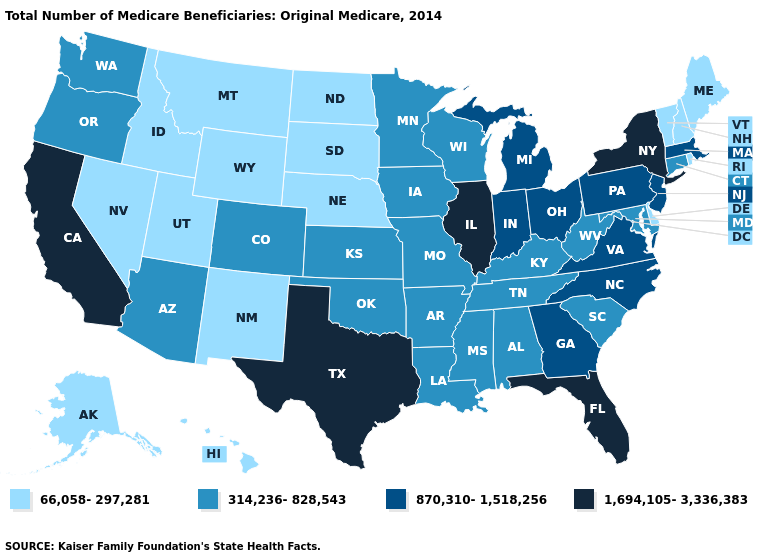What is the highest value in the West ?
Answer briefly. 1,694,105-3,336,383. What is the value of Iowa?
Short answer required. 314,236-828,543. Name the states that have a value in the range 1,694,105-3,336,383?
Short answer required. California, Florida, Illinois, New York, Texas. Name the states that have a value in the range 66,058-297,281?
Keep it brief. Alaska, Delaware, Hawaii, Idaho, Maine, Montana, Nebraska, Nevada, New Hampshire, New Mexico, North Dakota, Rhode Island, South Dakota, Utah, Vermont, Wyoming. Which states hav the highest value in the South?
Concise answer only. Florida, Texas. What is the lowest value in states that border New Hampshire?
Be succinct. 66,058-297,281. What is the value of Tennessee?
Write a very short answer. 314,236-828,543. Name the states that have a value in the range 66,058-297,281?
Keep it brief. Alaska, Delaware, Hawaii, Idaho, Maine, Montana, Nebraska, Nevada, New Hampshire, New Mexico, North Dakota, Rhode Island, South Dakota, Utah, Vermont, Wyoming. Name the states that have a value in the range 66,058-297,281?
Write a very short answer. Alaska, Delaware, Hawaii, Idaho, Maine, Montana, Nebraska, Nevada, New Hampshire, New Mexico, North Dakota, Rhode Island, South Dakota, Utah, Vermont, Wyoming. Does Idaho have the lowest value in the West?
Answer briefly. Yes. Name the states that have a value in the range 1,694,105-3,336,383?
Short answer required. California, Florida, Illinois, New York, Texas. Does California have the lowest value in the West?
Short answer required. No. What is the value of Arizona?
Be succinct. 314,236-828,543. Which states have the lowest value in the West?
Be succinct. Alaska, Hawaii, Idaho, Montana, Nevada, New Mexico, Utah, Wyoming. Name the states that have a value in the range 314,236-828,543?
Write a very short answer. Alabama, Arizona, Arkansas, Colorado, Connecticut, Iowa, Kansas, Kentucky, Louisiana, Maryland, Minnesota, Mississippi, Missouri, Oklahoma, Oregon, South Carolina, Tennessee, Washington, West Virginia, Wisconsin. 